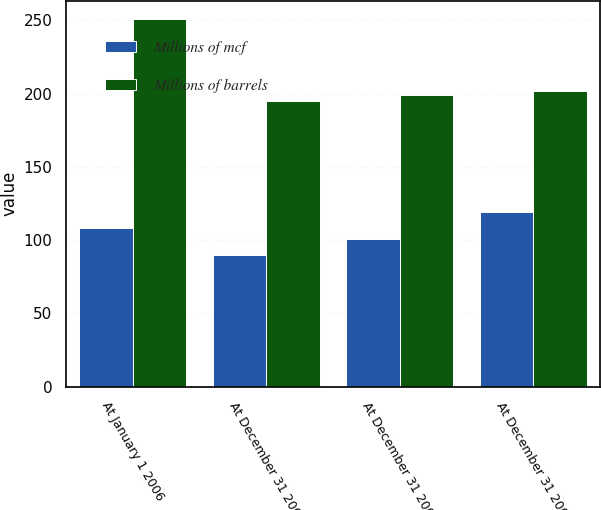Convert chart. <chart><loc_0><loc_0><loc_500><loc_500><stacked_bar_chart><ecel><fcel>At January 1 2006<fcel>At December 31 2006<fcel>At December 31 2007<fcel>At December 31 2008<nl><fcel>Millions of mcf<fcel>108<fcel>90<fcel>101<fcel>119<nl><fcel>Millions of barrels<fcel>251<fcel>195<fcel>199<fcel>202<nl></chart> 